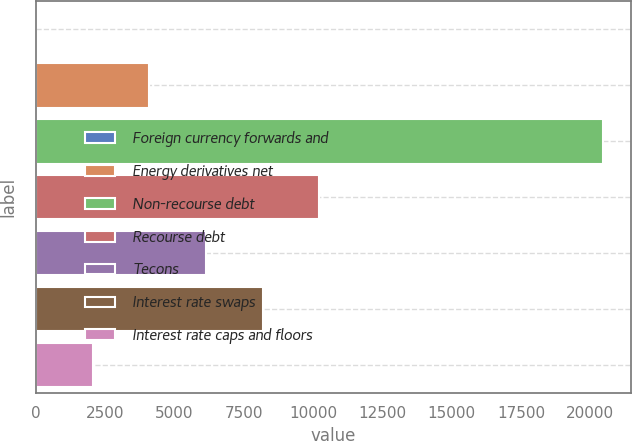Convert chart. <chart><loc_0><loc_0><loc_500><loc_500><bar_chart><fcel>Foreign currency forwards and<fcel>Energy derivatives net<fcel>Non-recourse debt<fcel>Recourse debt<fcel>Tecons<fcel>Interest rate swaps<fcel>Interest rate caps and floors<nl><fcel>17<fcel>4103<fcel>20447<fcel>10232<fcel>6146<fcel>8189<fcel>2060<nl></chart> 